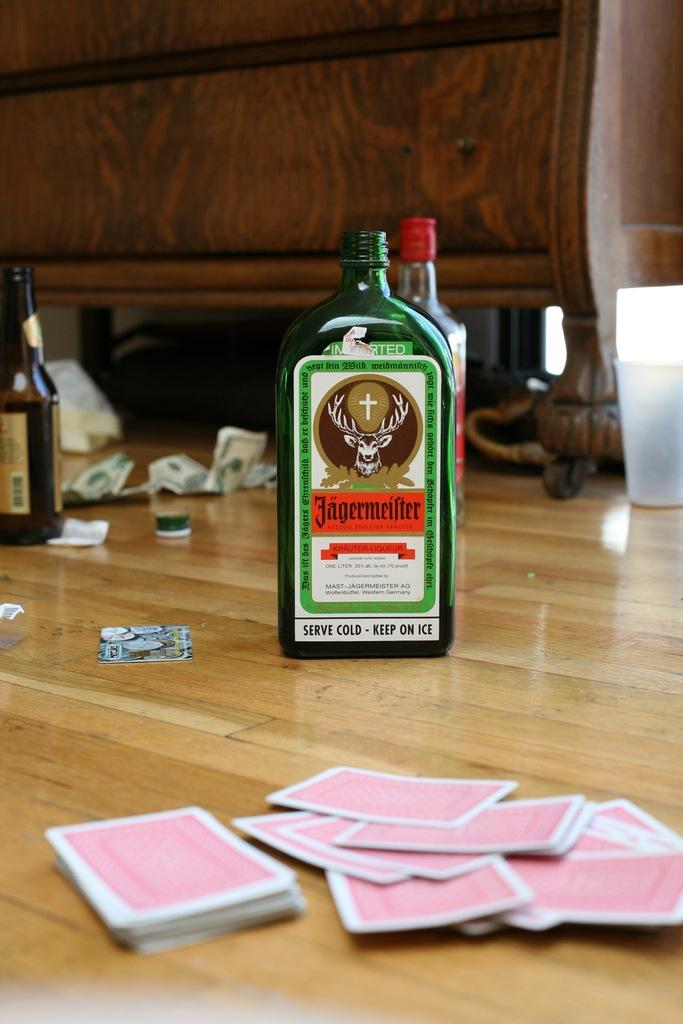<image>
Give a short and clear explanation of the subsequent image. Green alcohol bottle which says that it should be kept on ice. 